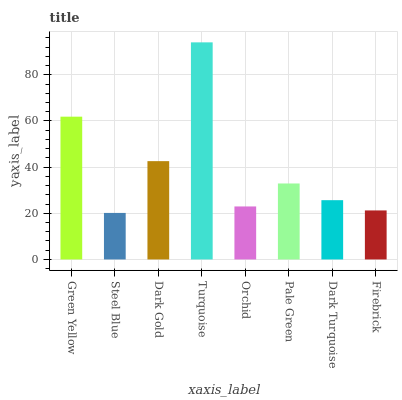Is Turquoise the maximum?
Answer yes or no. Yes. Is Dark Gold the minimum?
Answer yes or no. No. Is Dark Gold the maximum?
Answer yes or no. No. Is Dark Gold greater than Steel Blue?
Answer yes or no. Yes. Is Steel Blue less than Dark Gold?
Answer yes or no. Yes. Is Steel Blue greater than Dark Gold?
Answer yes or no. No. Is Dark Gold less than Steel Blue?
Answer yes or no. No. Is Pale Green the high median?
Answer yes or no. Yes. Is Dark Turquoise the low median?
Answer yes or no. Yes. Is Dark Gold the high median?
Answer yes or no. No. Is Steel Blue the low median?
Answer yes or no. No. 